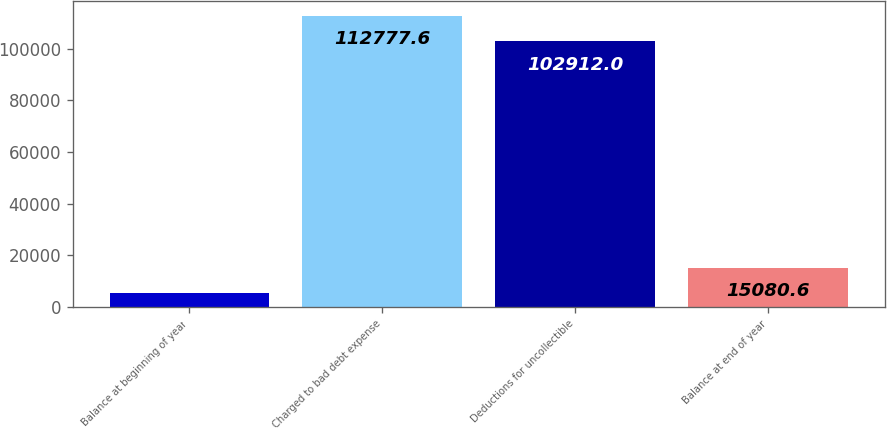<chart> <loc_0><loc_0><loc_500><loc_500><bar_chart><fcel>Balance at beginning of year<fcel>Charged to bad debt expense<fcel>Deductions for uncollectible<fcel>Balance at end of year<nl><fcel>5215<fcel>112778<fcel>102912<fcel>15080.6<nl></chart> 